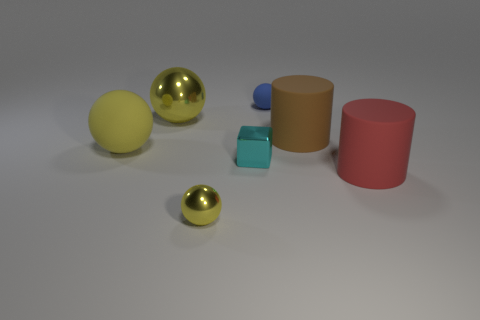Subtract all big rubber balls. How many balls are left? 3 Subtract all green cubes. How many yellow balls are left? 3 Subtract all blue balls. How many balls are left? 3 Subtract 2 balls. How many balls are left? 2 Subtract all purple balls. Subtract all red cylinders. How many balls are left? 4 Add 3 purple rubber spheres. How many objects exist? 10 Subtract all cylinders. How many objects are left? 5 Subtract all tiny yellow things. Subtract all cyan objects. How many objects are left? 5 Add 2 cyan metal things. How many cyan metal things are left? 3 Add 1 yellow metallic things. How many yellow metallic things exist? 3 